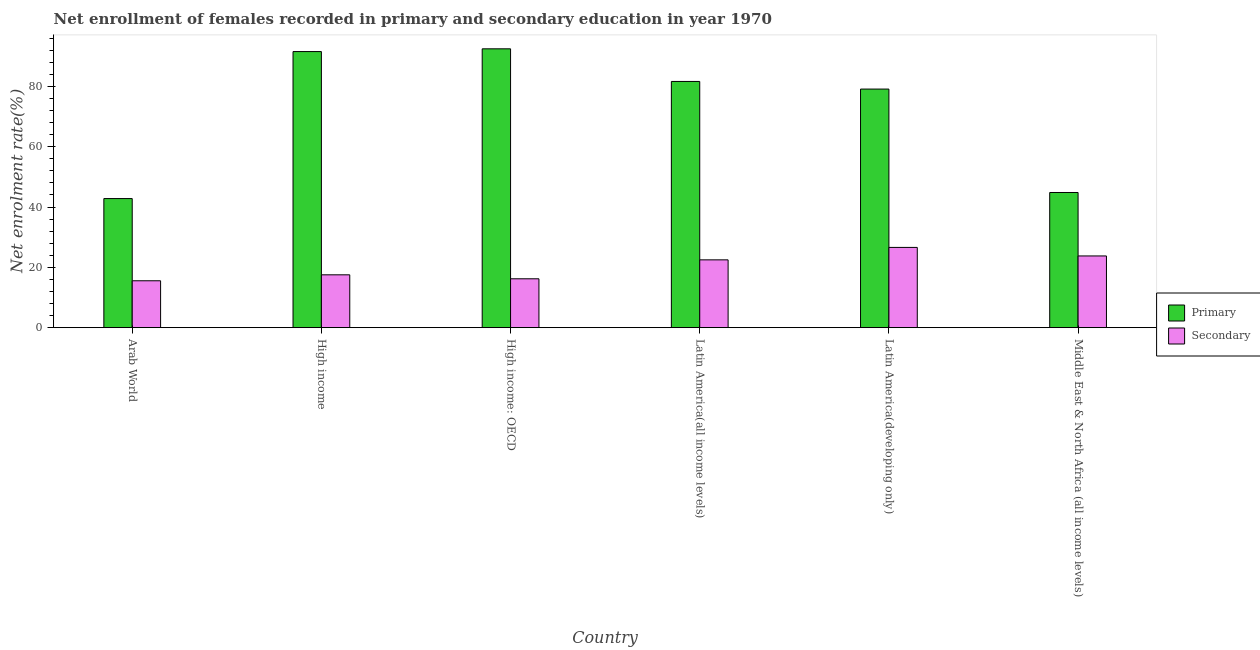How many different coloured bars are there?
Your answer should be compact. 2. How many groups of bars are there?
Give a very brief answer. 6. Are the number of bars on each tick of the X-axis equal?
Provide a succinct answer. Yes. What is the label of the 4th group of bars from the left?
Keep it short and to the point. Latin America(all income levels). In how many cases, is the number of bars for a given country not equal to the number of legend labels?
Keep it short and to the point. 0. What is the enrollment rate in primary education in Arab World?
Ensure brevity in your answer.  42.8. Across all countries, what is the maximum enrollment rate in primary education?
Provide a succinct answer. 92.45. Across all countries, what is the minimum enrollment rate in primary education?
Offer a terse response. 42.8. In which country was the enrollment rate in secondary education maximum?
Provide a succinct answer. Latin America(developing only). In which country was the enrollment rate in secondary education minimum?
Keep it short and to the point. Arab World. What is the total enrollment rate in secondary education in the graph?
Your answer should be very brief. 122.13. What is the difference between the enrollment rate in primary education in High income: OECD and that in Latin America(developing only)?
Your answer should be compact. 13.35. What is the difference between the enrollment rate in primary education in High income and the enrollment rate in secondary education in Middle East & North Africa (all income levels)?
Your response must be concise. 67.76. What is the average enrollment rate in secondary education per country?
Offer a terse response. 20.36. What is the difference between the enrollment rate in secondary education and enrollment rate in primary education in Latin America(all income levels)?
Keep it short and to the point. -59.15. In how many countries, is the enrollment rate in primary education greater than 4 %?
Provide a short and direct response. 6. What is the ratio of the enrollment rate in secondary education in High income: OECD to that in Latin America(developing only)?
Keep it short and to the point. 0.61. Is the enrollment rate in secondary education in Arab World less than that in High income?
Your answer should be very brief. Yes. Is the difference between the enrollment rate in primary education in Arab World and High income greater than the difference between the enrollment rate in secondary education in Arab World and High income?
Your answer should be very brief. No. What is the difference between the highest and the second highest enrollment rate in primary education?
Keep it short and to the point. 0.91. What is the difference between the highest and the lowest enrollment rate in primary education?
Your answer should be compact. 49.65. Is the sum of the enrollment rate in primary education in High income and Latin America(developing only) greater than the maximum enrollment rate in secondary education across all countries?
Ensure brevity in your answer.  Yes. What does the 2nd bar from the left in Middle East & North Africa (all income levels) represents?
Provide a succinct answer. Secondary. What does the 2nd bar from the right in Latin America(all income levels) represents?
Make the answer very short. Primary. Are the values on the major ticks of Y-axis written in scientific E-notation?
Provide a succinct answer. No. Does the graph contain any zero values?
Your response must be concise. No. Does the graph contain grids?
Keep it short and to the point. No. How are the legend labels stacked?
Make the answer very short. Vertical. What is the title of the graph?
Your answer should be compact. Net enrollment of females recorded in primary and secondary education in year 1970. What is the label or title of the X-axis?
Give a very brief answer. Country. What is the label or title of the Y-axis?
Offer a terse response. Net enrolment rate(%). What is the Net enrolment rate(%) of Primary in Arab World?
Keep it short and to the point. 42.8. What is the Net enrolment rate(%) in Secondary in Arab World?
Offer a terse response. 15.54. What is the Net enrolment rate(%) in Primary in High income?
Give a very brief answer. 91.54. What is the Net enrolment rate(%) in Secondary in High income?
Offer a terse response. 17.52. What is the Net enrolment rate(%) of Primary in High income: OECD?
Keep it short and to the point. 92.45. What is the Net enrolment rate(%) of Secondary in High income: OECD?
Your answer should be very brief. 16.2. What is the Net enrolment rate(%) in Primary in Latin America(all income levels)?
Give a very brief answer. 81.63. What is the Net enrolment rate(%) in Secondary in Latin America(all income levels)?
Make the answer very short. 22.48. What is the Net enrolment rate(%) in Primary in Latin America(developing only)?
Offer a very short reply. 79.11. What is the Net enrolment rate(%) of Secondary in Latin America(developing only)?
Make the answer very short. 26.61. What is the Net enrolment rate(%) of Primary in Middle East & North Africa (all income levels)?
Provide a short and direct response. 44.82. What is the Net enrolment rate(%) in Secondary in Middle East & North Africa (all income levels)?
Keep it short and to the point. 23.78. Across all countries, what is the maximum Net enrolment rate(%) in Primary?
Make the answer very short. 92.45. Across all countries, what is the maximum Net enrolment rate(%) of Secondary?
Make the answer very short. 26.61. Across all countries, what is the minimum Net enrolment rate(%) of Primary?
Your response must be concise. 42.8. Across all countries, what is the minimum Net enrolment rate(%) in Secondary?
Give a very brief answer. 15.54. What is the total Net enrolment rate(%) in Primary in the graph?
Make the answer very short. 432.35. What is the total Net enrolment rate(%) of Secondary in the graph?
Your answer should be very brief. 122.13. What is the difference between the Net enrolment rate(%) in Primary in Arab World and that in High income?
Your answer should be compact. -48.73. What is the difference between the Net enrolment rate(%) of Secondary in Arab World and that in High income?
Offer a terse response. -1.98. What is the difference between the Net enrolment rate(%) in Primary in Arab World and that in High income: OECD?
Provide a short and direct response. -49.65. What is the difference between the Net enrolment rate(%) in Secondary in Arab World and that in High income: OECD?
Offer a very short reply. -0.66. What is the difference between the Net enrolment rate(%) in Primary in Arab World and that in Latin America(all income levels)?
Provide a short and direct response. -38.83. What is the difference between the Net enrolment rate(%) of Secondary in Arab World and that in Latin America(all income levels)?
Keep it short and to the point. -6.94. What is the difference between the Net enrolment rate(%) of Primary in Arab World and that in Latin America(developing only)?
Make the answer very short. -36.3. What is the difference between the Net enrolment rate(%) of Secondary in Arab World and that in Latin America(developing only)?
Your answer should be very brief. -11.06. What is the difference between the Net enrolment rate(%) in Primary in Arab World and that in Middle East & North Africa (all income levels)?
Offer a very short reply. -2.01. What is the difference between the Net enrolment rate(%) in Secondary in Arab World and that in Middle East & North Africa (all income levels)?
Offer a very short reply. -8.23. What is the difference between the Net enrolment rate(%) of Primary in High income and that in High income: OECD?
Make the answer very short. -0.91. What is the difference between the Net enrolment rate(%) of Secondary in High income and that in High income: OECD?
Provide a short and direct response. 1.32. What is the difference between the Net enrolment rate(%) in Primary in High income and that in Latin America(all income levels)?
Your answer should be very brief. 9.9. What is the difference between the Net enrolment rate(%) in Secondary in High income and that in Latin America(all income levels)?
Your answer should be compact. -4.96. What is the difference between the Net enrolment rate(%) in Primary in High income and that in Latin America(developing only)?
Ensure brevity in your answer.  12.43. What is the difference between the Net enrolment rate(%) in Secondary in High income and that in Latin America(developing only)?
Keep it short and to the point. -9.09. What is the difference between the Net enrolment rate(%) of Primary in High income and that in Middle East & North Africa (all income levels)?
Your answer should be very brief. 46.72. What is the difference between the Net enrolment rate(%) of Secondary in High income and that in Middle East & North Africa (all income levels)?
Offer a terse response. -6.26. What is the difference between the Net enrolment rate(%) in Primary in High income: OECD and that in Latin America(all income levels)?
Provide a short and direct response. 10.82. What is the difference between the Net enrolment rate(%) of Secondary in High income: OECD and that in Latin America(all income levels)?
Your answer should be very brief. -6.28. What is the difference between the Net enrolment rate(%) in Primary in High income: OECD and that in Latin America(developing only)?
Your answer should be very brief. 13.35. What is the difference between the Net enrolment rate(%) of Secondary in High income: OECD and that in Latin America(developing only)?
Ensure brevity in your answer.  -10.4. What is the difference between the Net enrolment rate(%) in Primary in High income: OECD and that in Middle East & North Africa (all income levels)?
Give a very brief answer. 47.63. What is the difference between the Net enrolment rate(%) of Secondary in High income: OECD and that in Middle East & North Africa (all income levels)?
Provide a succinct answer. -7.58. What is the difference between the Net enrolment rate(%) of Primary in Latin America(all income levels) and that in Latin America(developing only)?
Provide a short and direct response. 2.53. What is the difference between the Net enrolment rate(%) of Secondary in Latin America(all income levels) and that in Latin America(developing only)?
Your answer should be very brief. -4.12. What is the difference between the Net enrolment rate(%) of Primary in Latin America(all income levels) and that in Middle East & North Africa (all income levels)?
Offer a terse response. 36.82. What is the difference between the Net enrolment rate(%) in Secondary in Latin America(all income levels) and that in Middle East & North Africa (all income levels)?
Give a very brief answer. -1.3. What is the difference between the Net enrolment rate(%) of Primary in Latin America(developing only) and that in Middle East & North Africa (all income levels)?
Your answer should be compact. 34.29. What is the difference between the Net enrolment rate(%) of Secondary in Latin America(developing only) and that in Middle East & North Africa (all income levels)?
Offer a terse response. 2.83. What is the difference between the Net enrolment rate(%) of Primary in Arab World and the Net enrolment rate(%) of Secondary in High income?
Provide a succinct answer. 25.28. What is the difference between the Net enrolment rate(%) in Primary in Arab World and the Net enrolment rate(%) in Secondary in High income: OECD?
Ensure brevity in your answer.  26.6. What is the difference between the Net enrolment rate(%) in Primary in Arab World and the Net enrolment rate(%) in Secondary in Latin America(all income levels)?
Your answer should be compact. 20.32. What is the difference between the Net enrolment rate(%) in Primary in Arab World and the Net enrolment rate(%) in Secondary in Latin America(developing only)?
Give a very brief answer. 16.2. What is the difference between the Net enrolment rate(%) of Primary in Arab World and the Net enrolment rate(%) of Secondary in Middle East & North Africa (all income levels)?
Your answer should be very brief. 19.03. What is the difference between the Net enrolment rate(%) in Primary in High income and the Net enrolment rate(%) in Secondary in High income: OECD?
Give a very brief answer. 75.34. What is the difference between the Net enrolment rate(%) of Primary in High income and the Net enrolment rate(%) of Secondary in Latin America(all income levels)?
Offer a terse response. 69.06. What is the difference between the Net enrolment rate(%) in Primary in High income and the Net enrolment rate(%) in Secondary in Latin America(developing only)?
Provide a succinct answer. 64.93. What is the difference between the Net enrolment rate(%) of Primary in High income and the Net enrolment rate(%) of Secondary in Middle East & North Africa (all income levels)?
Your response must be concise. 67.76. What is the difference between the Net enrolment rate(%) of Primary in High income: OECD and the Net enrolment rate(%) of Secondary in Latin America(all income levels)?
Your answer should be very brief. 69.97. What is the difference between the Net enrolment rate(%) of Primary in High income: OECD and the Net enrolment rate(%) of Secondary in Latin America(developing only)?
Make the answer very short. 65.85. What is the difference between the Net enrolment rate(%) of Primary in High income: OECD and the Net enrolment rate(%) of Secondary in Middle East & North Africa (all income levels)?
Provide a short and direct response. 68.68. What is the difference between the Net enrolment rate(%) in Primary in Latin America(all income levels) and the Net enrolment rate(%) in Secondary in Latin America(developing only)?
Keep it short and to the point. 55.03. What is the difference between the Net enrolment rate(%) of Primary in Latin America(all income levels) and the Net enrolment rate(%) of Secondary in Middle East & North Africa (all income levels)?
Keep it short and to the point. 57.86. What is the difference between the Net enrolment rate(%) in Primary in Latin America(developing only) and the Net enrolment rate(%) in Secondary in Middle East & North Africa (all income levels)?
Your response must be concise. 55.33. What is the average Net enrolment rate(%) in Primary per country?
Your answer should be compact. 72.06. What is the average Net enrolment rate(%) of Secondary per country?
Provide a short and direct response. 20.36. What is the difference between the Net enrolment rate(%) of Primary and Net enrolment rate(%) of Secondary in Arab World?
Ensure brevity in your answer.  27.26. What is the difference between the Net enrolment rate(%) of Primary and Net enrolment rate(%) of Secondary in High income?
Provide a succinct answer. 74.02. What is the difference between the Net enrolment rate(%) of Primary and Net enrolment rate(%) of Secondary in High income: OECD?
Make the answer very short. 76.25. What is the difference between the Net enrolment rate(%) in Primary and Net enrolment rate(%) in Secondary in Latin America(all income levels)?
Provide a short and direct response. 59.15. What is the difference between the Net enrolment rate(%) in Primary and Net enrolment rate(%) in Secondary in Latin America(developing only)?
Give a very brief answer. 52.5. What is the difference between the Net enrolment rate(%) of Primary and Net enrolment rate(%) of Secondary in Middle East & North Africa (all income levels)?
Provide a succinct answer. 21.04. What is the ratio of the Net enrolment rate(%) of Primary in Arab World to that in High income?
Provide a succinct answer. 0.47. What is the ratio of the Net enrolment rate(%) of Secondary in Arab World to that in High income?
Your response must be concise. 0.89. What is the ratio of the Net enrolment rate(%) in Primary in Arab World to that in High income: OECD?
Offer a terse response. 0.46. What is the ratio of the Net enrolment rate(%) of Secondary in Arab World to that in High income: OECD?
Give a very brief answer. 0.96. What is the ratio of the Net enrolment rate(%) in Primary in Arab World to that in Latin America(all income levels)?
Provide a short and direct response. 0.52. What is the ratio of the Net enrolment rate(%) in Secondary in Arab World to that in Latin America(all income levels)?
Offer a terse response. 0.69. What is the ratio of the Net enrolment rate(%) of Primary in Arab World to that in Latin America(developing only)?
Your answer should be very brief. 0.54. What is the ratio of the Net enrolment rate(%) in Secondary in Arab World to that in Latin America(developing only)?
Give a very brief answer. 0.58. What is the ratio of the Net enrolment rate(%) in Primary in Arab World to that in Middle East & North Africa (all income levels)?
Provide a succinct answer. 0.96. What is the ratio of the Net enrolment rate(%) of Secondary in Arab World to that in Middle East & North Africa (all income levels)?
Keep it short and to the point. 0.65. What is the ratio of the Net enrolment rate(%) of Primary in High income to that in High income: OECD?
Keep it short and to the point. 0.99. What is the ratio of the Net enrolment rate(%) in Secondary in High income to that in High income: OECD?
Offer a terse response. 1.08. What is the ratio of the Net enrolment rate(%) in Primary in High income to that in Latin America(all income levels)?
Your answer should be very brief. 1.12. What is the ratio of the Net enrolment rate(%) in Secondary in High income to that in Latin America(all income levels)?
Keep it short and to the point. 0.78. What is the ratio of the Net enrolment rate(%) of Primary in High income to that in Latin America(developing only)?
Offer a terse response. 1.16. What is the ratio of the Net enrolment rate(%) in Secondary in High income to that in Latin America(developing only)?
Give a very brief answer. 0.66. What is the ratio of the Net enrolment rate(%) in Primary in High income to that in Middle East & North Africa (all income levels)?
Offer a very short reply. 2.04. What is the ratio of the Net enrolment rate(%) in Secondary in High income to that in Middle East & North Africa (all income levels)?
Make the answer very short. 0.74. What is the ratio of the Net enrolment rate(%) in Primary in High income: OECD to that in Latin America(all income levels)?
Provide a succinct answer. 1.13. What is the ratio of the Net enrolment rate(%) of Secondary in High income: OECD to that in Latin America(all income levels)?
Your answer should be very brief. 0.72. What is the ratio of the Net enrolment rate(%) in Primary in High income: OECD to that in Latin America(developing only)?
Your answer should be very brief. 1.17. What is the ratio of the Net enrolment rate(%) in Secondary in High income: OECD to that in Latin America(developing only)?
Offer a terse response. 0.61. What is the ratio of the Net enrolment rate(%) in Primary in High income: OECD to that in Middle East & North Africa (all income levels)?
Keep it short and to the point. 2.06. What is the ratio of the Net enrolment rate(%) in Secondary in High income: OECD to that in Middle East & North Africa (all income levels)?
Make the answer very short. 0.68. What is the ratio of the Net enrolment rate(%) in Primary in Latin America(all income levels) to that in Latin America(developing only)?
Your response must be concise. 1.03. What is the ratio of the Net enrolment rate(%) in Secondary in Latin America(all income levels) to that in Latin America(developing only)?
Keep it short and to the point. 0.84. What is the ratio of the Net enrolment rate(%) of Primary in Latin America(all income levels) to that in Middle East & North Africa (all income levels)?
Provide a succinct answer. 1.82. What is the ratio of the Net enrolment rate(%) in Secondary in Latin America(all income levels) to that in Middle East & North Africa (all income levels)?
Provide a succinct answer. 0.95. What is the ratio of the Net enrolment rate(%) in Primary in Latin America(developing only) to that in Middle East & North Africa (all income levels)?
Offer a very short reply. 1.76. What is the ratio of the Net enrolment rate(%) in Secondary in Latin America(developing only) to that in Middle East & North Africa (all income levels)?
Ensure brevity in your answer.  1.12. What is the difference between the highest and the second highest Net enrolment rate(%) of Primary?
Give a very brief answer. 0.91. What is the difference between the highest and the second highest Net enrolment rate(%) of Secondary?
Ensure brevity in your answer.  2.83. What is the difference between the highest and the lowest Net enrolment rate(%) of Primary?
Offer a terse response. 49.65. What is the difference between the highest and the lowest Net enrolment rate(%) in Secondary?
Offer a terse response. 11.06. 